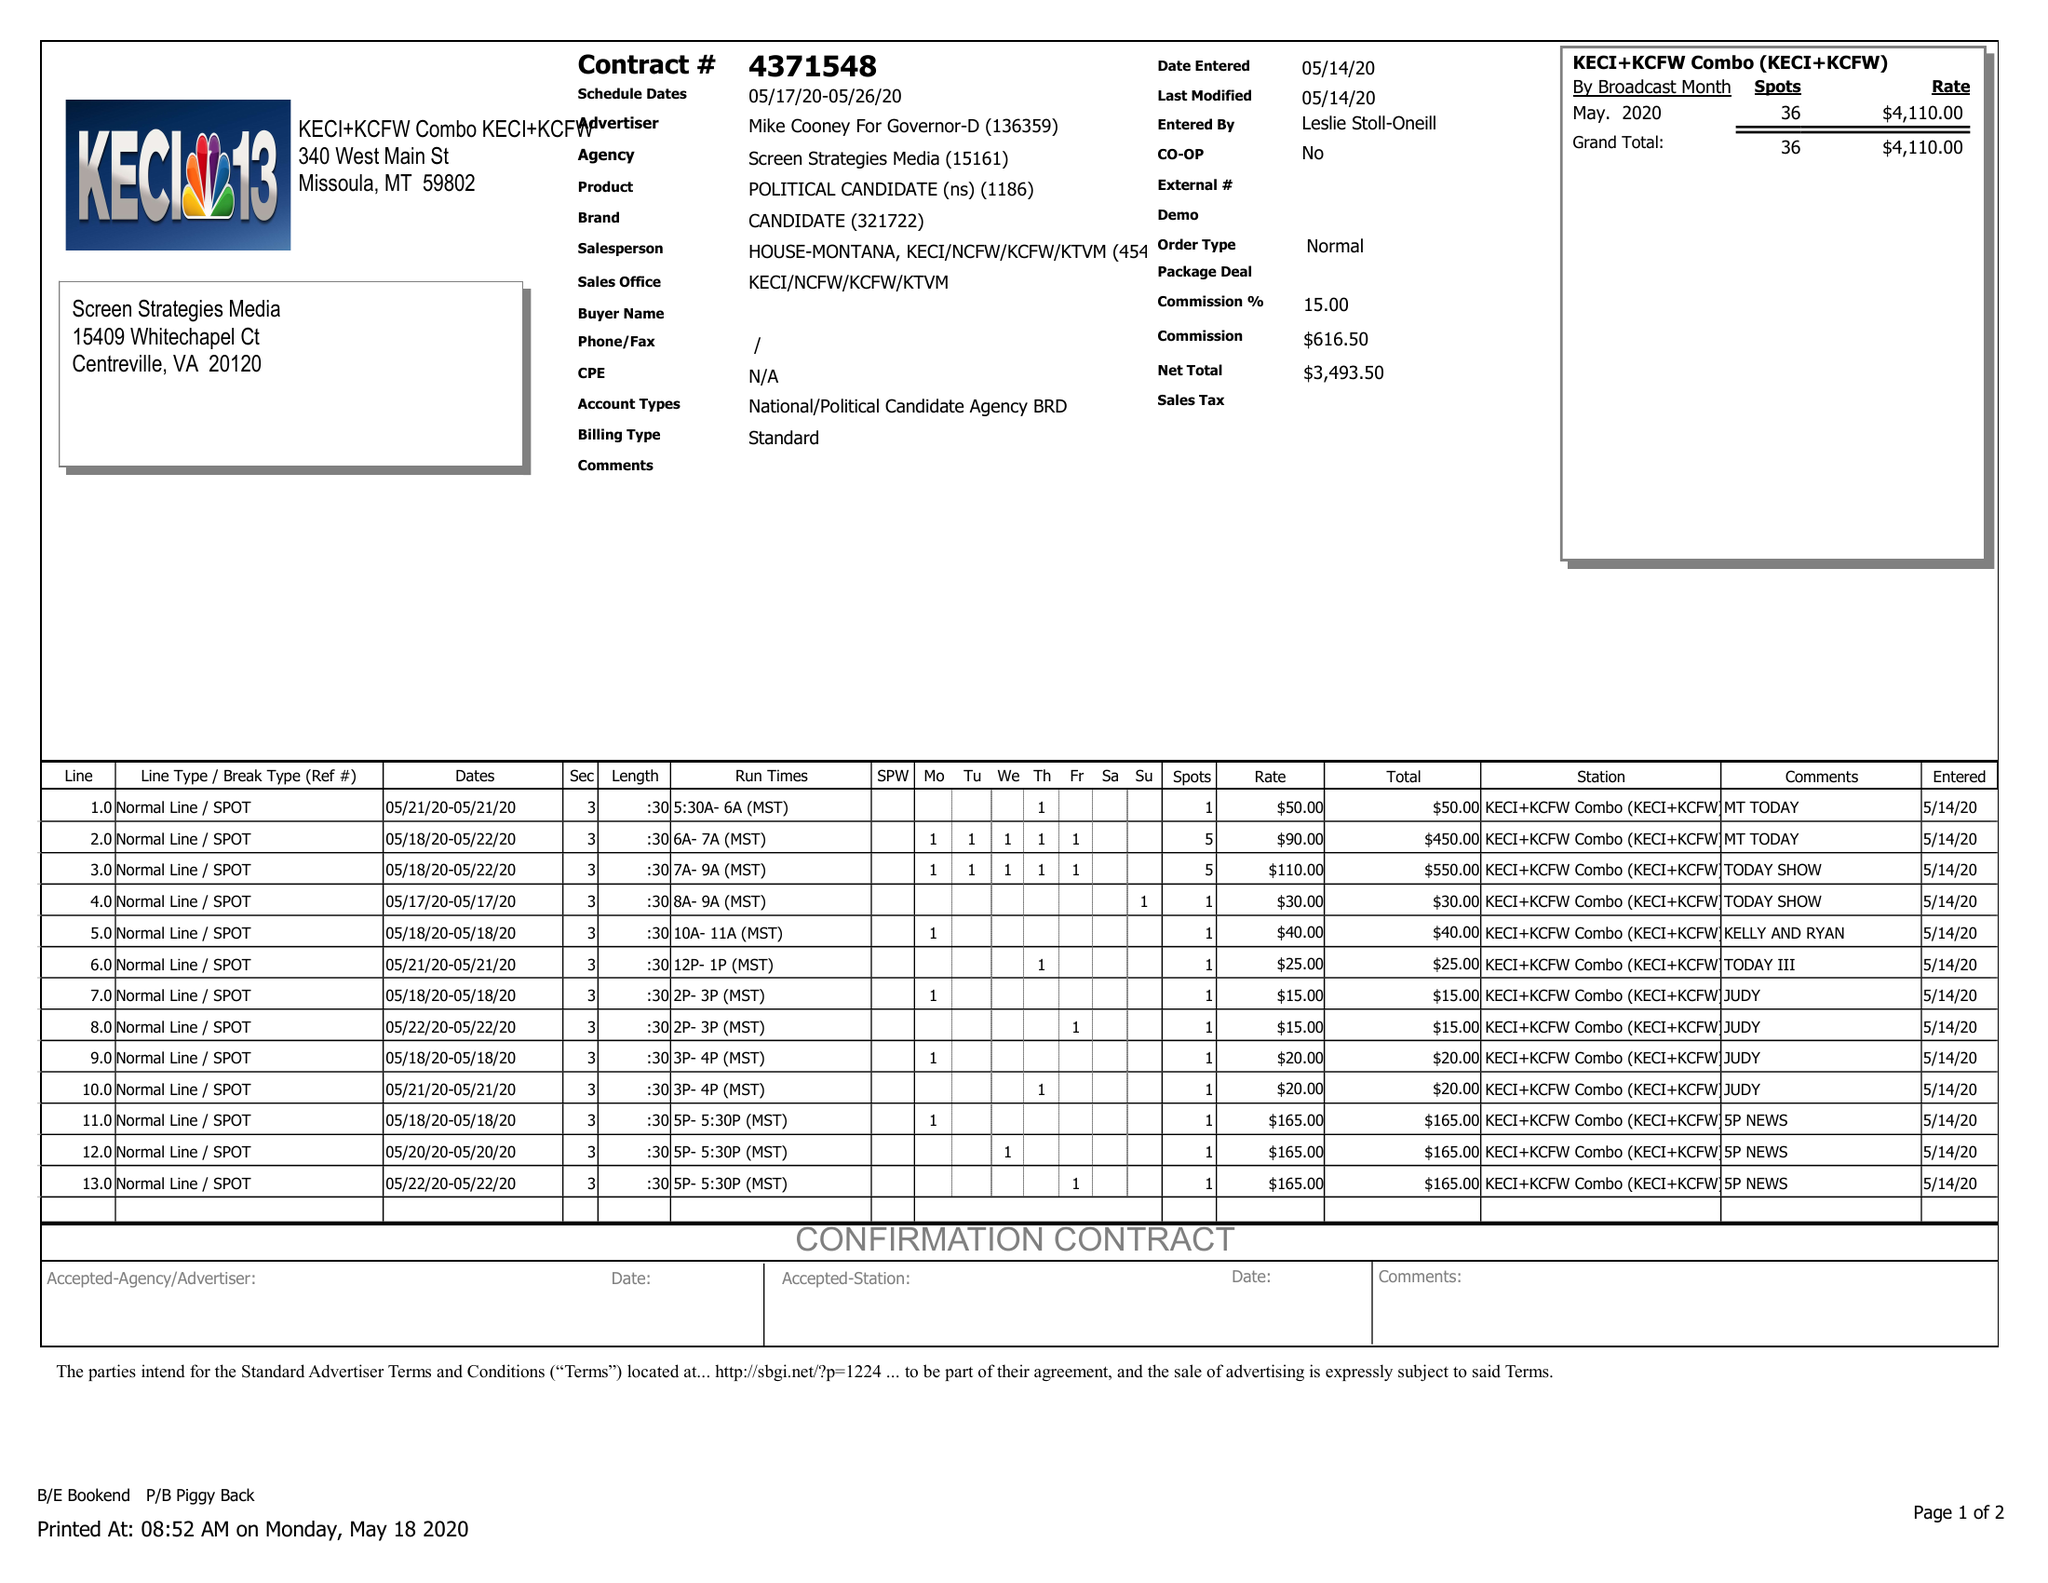What is the value for the contract_num?
Answer the question using a single word or phrase. 4371548 